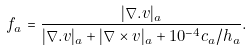Convert formula to latex. <formula><loc_0><loc_0><loc_500><loc_500>f _ { a } = \frac { | \nabla . v | _ { a } } { | \nabla . v | _ { a } + | \nabla \times v | _ { a } + 1 0 ^ { - 4 } c _ { a } / h _ { a } } .</formula> 